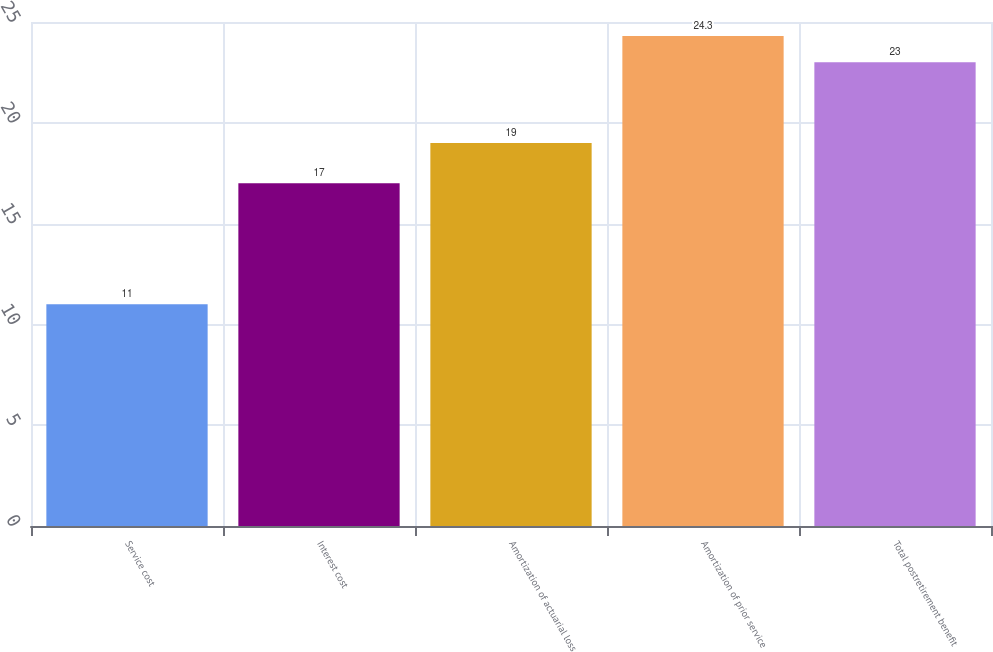Convert chart. <chart><loc_0><loc_0><loc_500><loc_500><bar_chart><fcel>Service cost<fcel>Interest cost<fcel>Amortization of actuarial loss<fcel>Amortization of prior service<fcel>Total postretirement benefit<nl><fcel>11<fcel>17<fcel>19<fcel>24.3<fcel>23<nl></chart> 